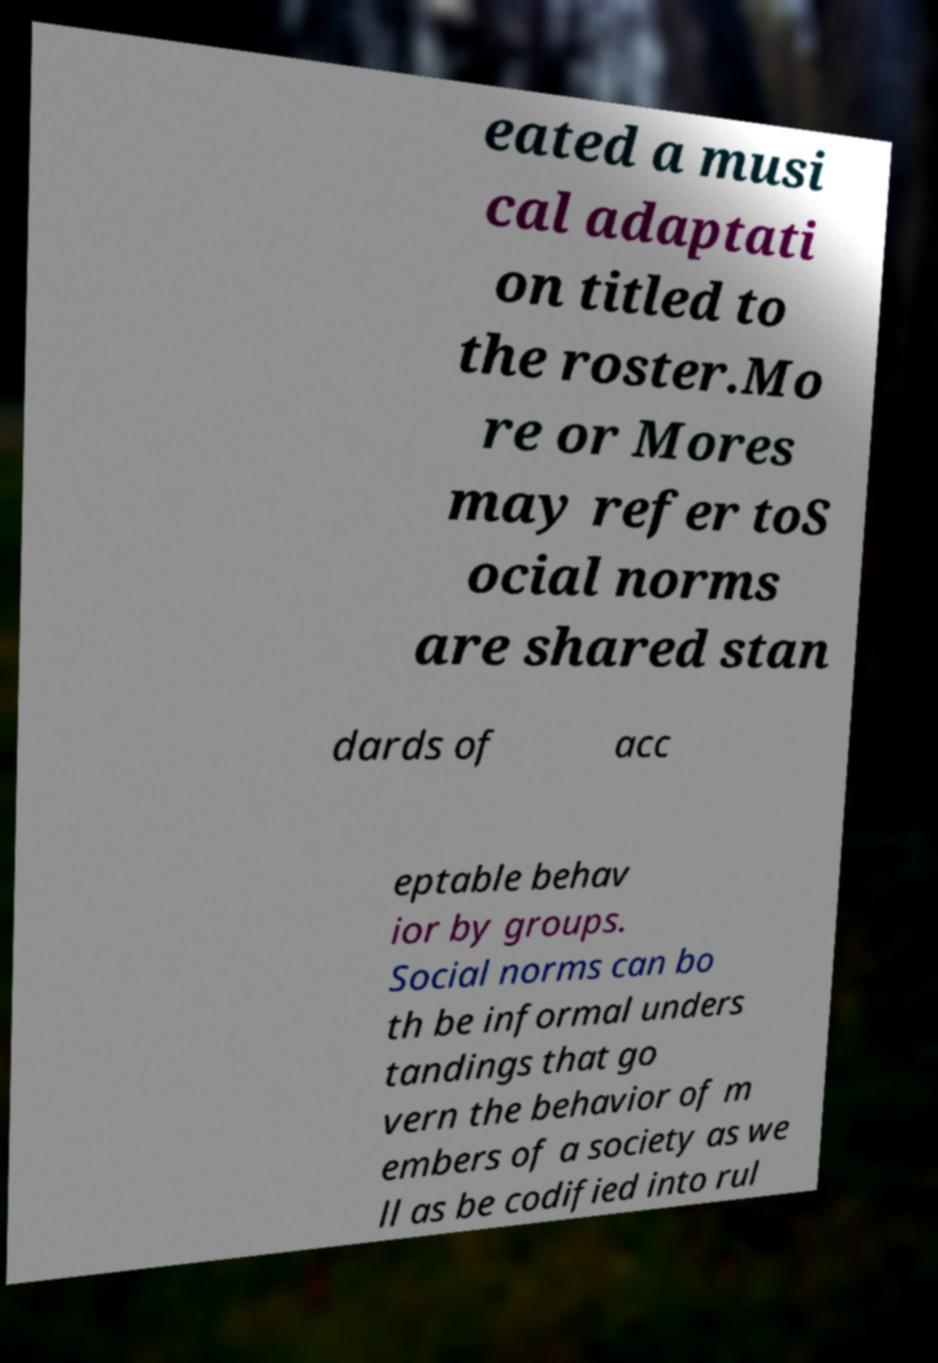There's text embedded in this image that I need extracted. Can you transcribe it verbatim? eated a musi cal adaptati on titled to the roster.Mo re or Mores may refer toS ocial norms are shared stan dards of acc eptable behav ior by groups. Social norms can bo th be informal unders tandings that go vern the behavior of m embers of a society as we ll as be codified into rul 